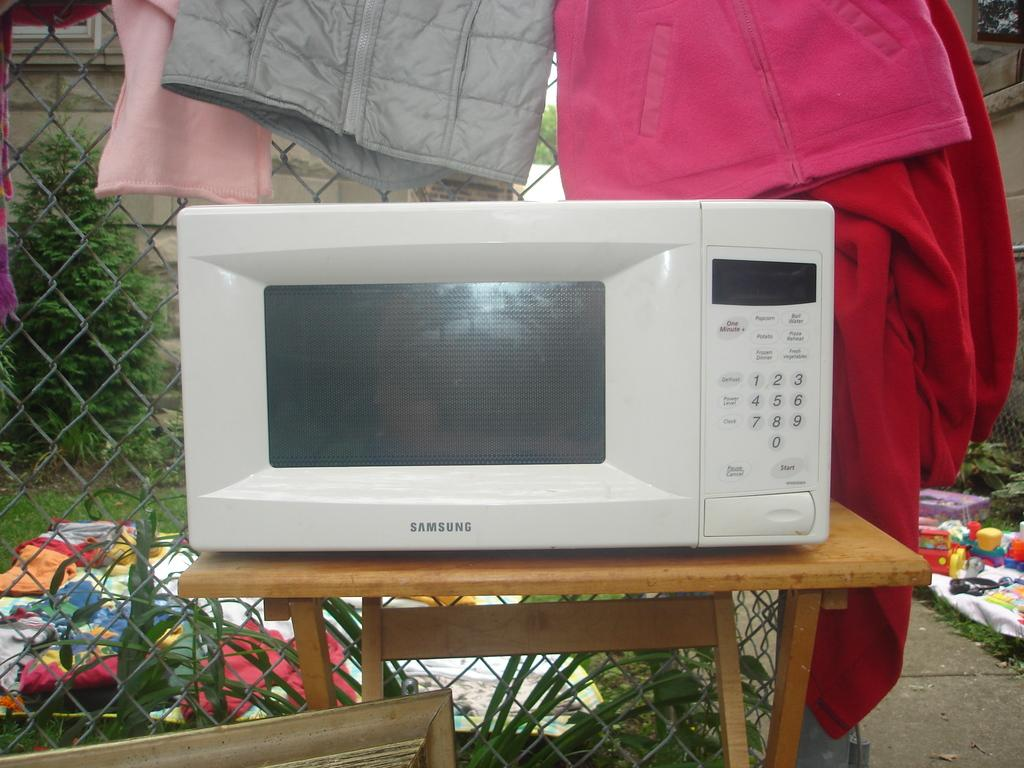<image>
Write a terse but informative summary of the picture. A Samsung microwave that is currently powered off 